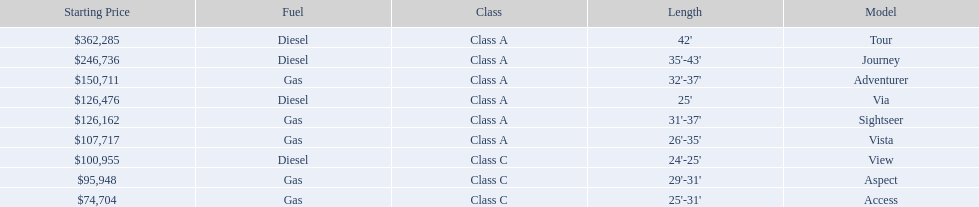Which models are manufactured by winnebago industries? Tour, Journey, Adventurer, Via, Sightseer, Vista, View, Aspect, Access. What type of fuel does each model require? Diesel, Diesel, Gas, Diesel, Gas, Gas, Diesel, Gas, Gas. And between the tour and aspect, which runs on diesel? Tour. 